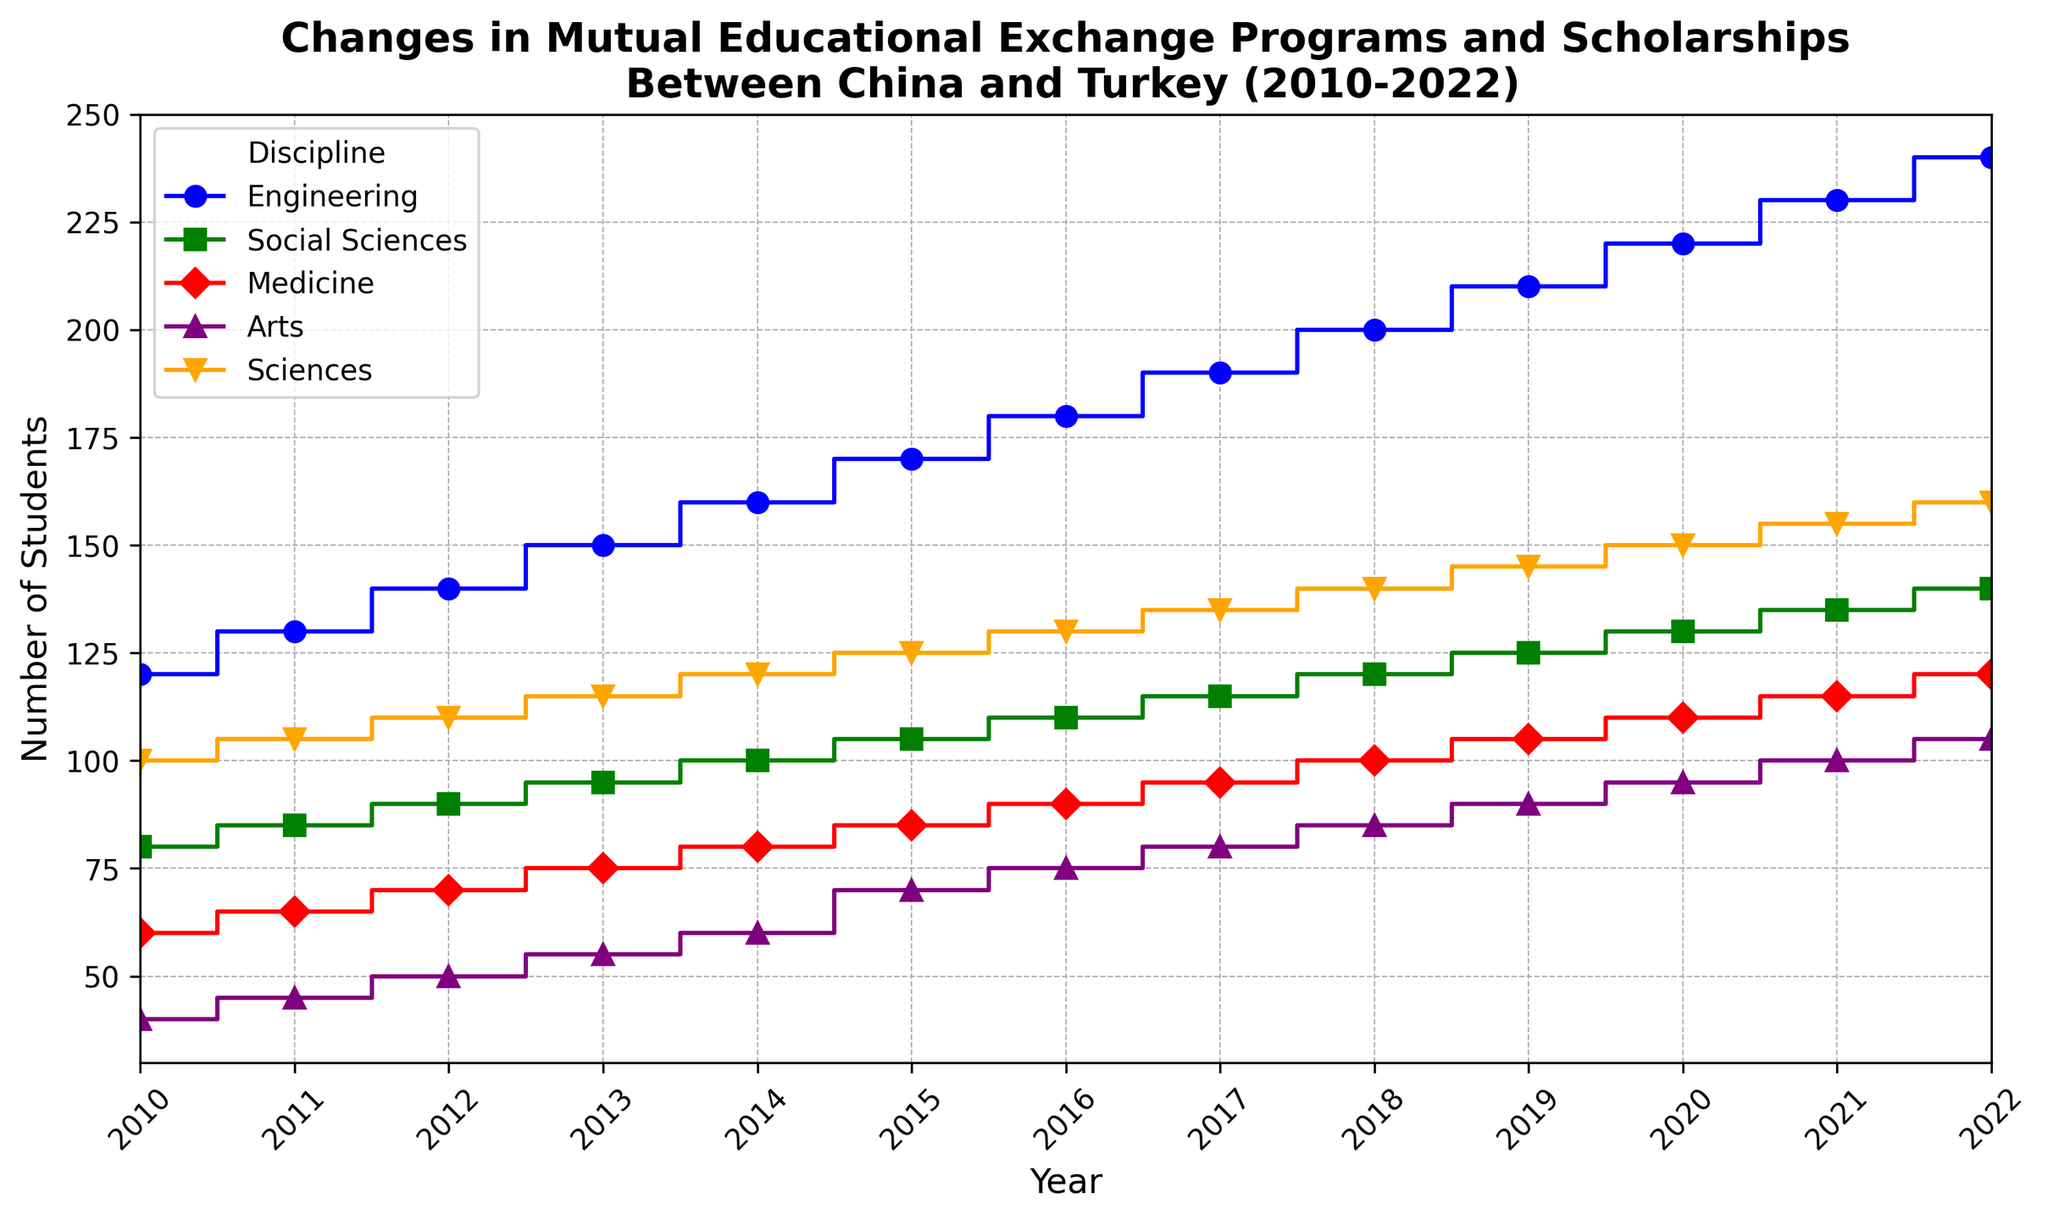what is the total number of students in Engineering in 2022? To find the total number of students in Engineering in 2022, identify the value for Engineering in the year 2022 on the plot. The value on the plot shows there are 240 students.
Answer: 240 which discipline had the largest increase in students from 2010 to 2022? To determine the discipline with the largest increase, subtract the number of students in 2010 from the number in 2022 for each discipline and compare the differences: Engineering: 240-120=120, Social Sciences: 140-80=60, Medicine: 120-60=60, Arts: 105-40=65, Sciences: 160-100=60. Engineering had the largest increase.
Answer: Engineering in what year did the number of students in Medicine equal 100? Check the plot for the Medicine discipline and find the year where it reaches 100 students. According to the plot, this occurred in the year 2018.
Answer: 2018 how many more students were there in Social Sciences compared to Arts in 2020? Look at the 2020 data points for Social Sciences and Arts. Social Sciences had 130 students and Arts had 95 students. Calculate the difference: 130 - 95 = 35.
Answer: 35 what is the average number of students in Sciences from 2010 to 2022? Calculate the average by summing the values for Sciences from 2010 to 2022 and then dividing by the number of years: (100+105+110+115+120+125+130+135+140+145+150+155+160)/13=123.08 (rounded to two decimals)
Answer: 123.08 in which year did Arts see the greatest year-over-year increase in students? To identify the greatest year-over-year increase, look at the Arts data on the plot and calculate the differences between each consecutive year. The largest increase is from 2014 to 2015, where the number of students increased from 60 to 70.
Answer: 2015 which discipline had the highest number of students in 2016? In the year 2016, compare the number of students across all disciplines: Engineering (180), Social Sciences (110), Medicine (90), Arts (75), Sciences (130). Engineering had the highest number of students.
Answer: Engineering how many total students were there across all disciplines in 2012? Add the number of students for all disciplines in the year 2012: 140 (Engineering) + 90 (Social Sciences) + 70 (Medicine) + 50 (Arts) + 110 (Sciences) = 460.
Answer: 460 which discipline displayed a consistent year-over-year increase in students from 2010 to 2022? By analyzing the plot, the discipline of Engineering shows a consistent year-over-year increase as the number of students rises steadily every year from 2010 to 2022.
Answer: Engineering 